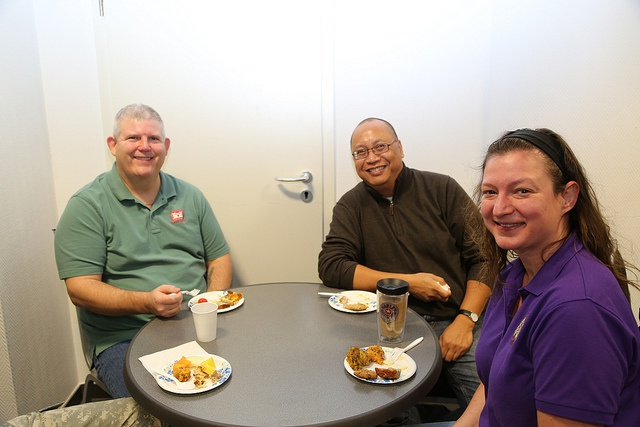Describe the objects in this image and their specific colors. I can see people in lavender, black, navy, purple, and maroon tones, people in lavender, gray, black, and darkgray tones, people in lavender, black, maroon, brown, and tan tones, dining table in lavender, darkgray, and gray tones, and cup in lavender, gray, maroon, and olive tones in this image. 